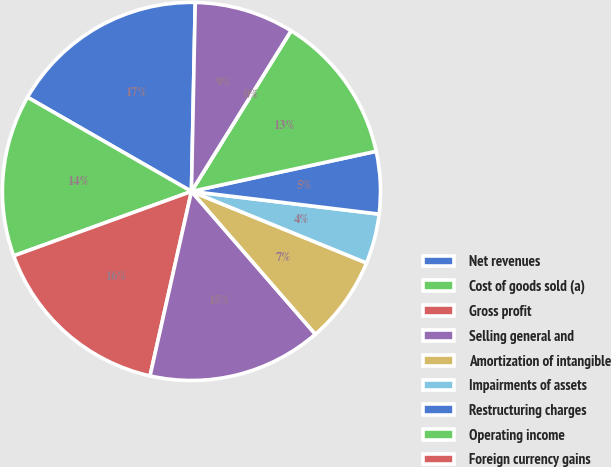<chart> <loc_0><loc_0><loc_500><loc_500><pie_chart><fcel>Net revenues<fcel>Cost of goods sold (a)<fcel>Gross profit<fcel>Selling general and<fcel>Amortization of intangible<fcel>Impairments of assets<fcel>Restructuring charges<fcel>Operating income<fcel>Foreign currency gains<fcel>Interest expense<nl><fcel>17.02%<fcel>13.83%<fcel>15.95%<fcel>14.89%<fcel>7.45%<fcel>4.26%<fcel>5.32%<fcel>12.76%<fcel>0.0%<fcel>8.51%<nl></chart> 